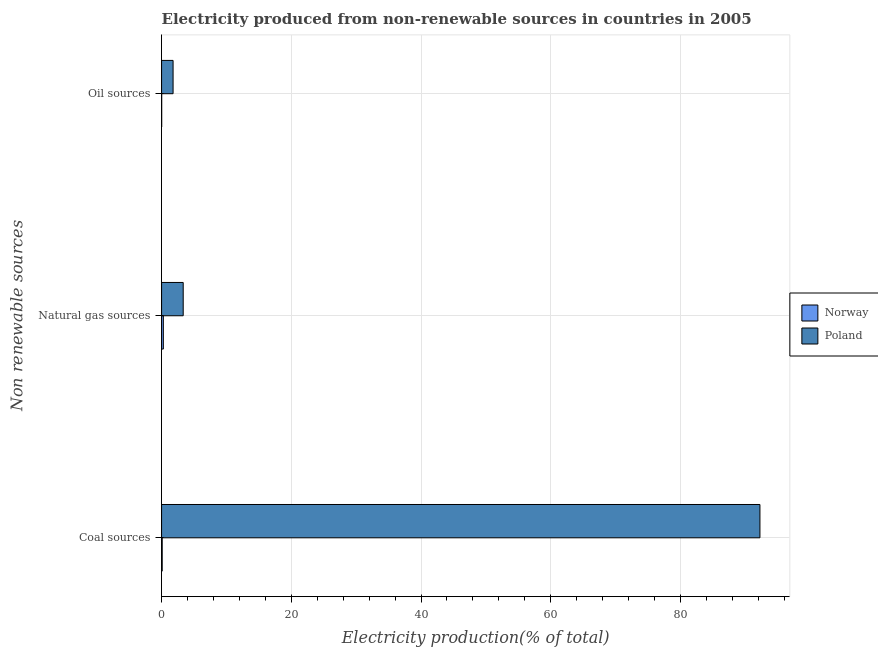How many different coloured bars are there?
Provide a short and direct response. 2. Are the number of bars per tick equal to the number of legend labels?
Offer a terse response. Yes. How many bars are there on the 3rd tick from the bottom?
Make the answer very short. 2. What is the label of the 3rd group of bars from the top?
Your answer should be very brief. Coal sources. What is the percentage of electricity produced by natural gas in Poland?
Give a very brief answer. 3.33. Across all countries, what is the maximum percentage of electricity produced by oil sources?
Offer a terse response. 1.77. Across all countries, what is the minimum percentage of electricity produced by natural gas?
Keep it short and to the point. 0.27. What is the total percentage of electricity produced by oil sources in the graph?
Make the answer very short. 1.79. What is the difference between the percentage of electricity produced by natural gas in Norway and that in Poland?
Make the answer very short. -3.06. What is the difference between the percentage of electricity produced by coal in Norway and the percentage of electricity produced by oil sources in Poland?
Offer a terse response. -1.68. What is the average percentage of electricity produced by natural gas per country?
Give a very brief answer. 1.8. What is the difference between the percentage of electricity produced by coal and percentage of electricity produced by natural gas in Norway?
Make the answer very short. -0.18. What is the ratio of the percentage of electricity produced by natural gas in Poland to that in Norway?
Ensure brevity in your answer.  12.21. What is the difference between the highest and the second highest percentage of electricity produced by natural gas?
Offer a terse response. 3.06. What is the difference between the highest and the lowest percentage of electricity produced by natural gas?
Keep it short and to the point. 3.06. In how many countries, is the percentage of electricity produced by natural gas greater than the average percentage of electricity produced by natural gas taken over all countries?
Offer a very short reply. 1. Is the sum of the percentage of electricity produced by coal in Norway and Poland greater than the maximum percentage of electricity produced by natural gas across all countries?
Provide a short and direct response. Yes. What does the 1st bar from the top in Oil sources represents?
Provide a succinct answer. Poland. Is it the case that in every country, the sum of the percentage of electricity produced by coal and percentage of electricity produced by natural gas is greater than the percentage of electricity produced by oil sources?
Offer a very short reply. Yes. How many bars are there?
Keep it short and to the point. 6. Are all the bars in the graph horizontal?
Provide a succinct answer. Yes. How many countries are there in the graph?
Give a very brief answer. 2. How are the legend labels stacked?
Offer a terse response. Vertical. What is the title of the graph?
Keep it short and to the point. Electricity produced from non-renewable sources in countries in 2005. What is the label or title of the Y-axis?
Provide a short and direct response. Non renewable sources. What is the Electricity production(% of total) in Norway in Coal sources?
Ensure brevity in your answer.  0.1. What is the Electricity production(% of total) in Poland in Coal sources?
Give a very brief answer. 92.26. What is the Electricity production(% of total) of Norway in Natural gas sources?
Ensure brevity in your answer.  0.27. What is the Electricity production(% of total) of Poland in Natural gas sources?
Provide a short and direct response. 3.33. What is the Electricity production(% of total) in Norway in Oil sources?
Offer a very short reply. 0.02. What is the Electricity production(% of total) in Poland in Oil sources?
Keep it short and to the point. 1.77. Across all Non renewable sources, what is the maximum Electricity production(% of total) in Norway?
Make the answer very short. 0.27. Across all Non renewable sources, what is the maximum Electricity production(% of total) in Poland?
Your answer should be very brief. 92.26. Across all Non renewable sources, what is the minimum Electricity production(% of total) of Norway?
Make the answer very short. 0.02. Across all Non renewable sources, what is the minimum Electricity production(% of total) of Poland?
Ensure brevity in your answer.  1.77. What is the total Electricity production(% of total) of Norway in the graph?
Your response must be concise. 0.39. What is the total Electricity production(% of total) in Poland in the graph?
Make the answer very short. 97.37. What is the difference between the Electricity production(% of total) of Norway in Coal sources and that in Natural gas sources?
Keep it short and to the point. -0.18. What is the difference between the Electricity production(% of total) in Poland in Coal sources and that in Natural gas sources?
Your answer should be compact. 88.93. What is the difference between the Electricity production(% of total) of Norway in Coal sources and that in Oil sources?
Your response must be concise. 0.08. What is the difference between the Electricity production(% of total) in Poland in Coal sources and that in Oil sources?
Make the answer very short. 90.49. What is the difference between the Electricity production(% of total) in Norway in Natural gas sources and that in Oil sources?
Offer a very short reply. 0.26. What is the difference between the Electricity production(% of total) in Poland in Natural gas sources and that in Oil sources?
Ensure brevity in your answer.  1.56. What is the difference between the Electricity production(% of total) in Norway in Coal sources and the Electricity production(% of total) in Poland in Natural gas sources?
Your answer should be very brief. -3.24. What is the difference between the Electricity production(% of total) in Norway in Coal sources and the Electricity production(% of total) in Poland in Oil sources?
Provide a short and direct response. -1.68. What is the difference between the Electricity production(% of total) in Norway in Natural gas sources and the Electricity production(% of total) in Poland in Oil sources?
Ensure brevity in your answer.  -1.5. What is the average Electricity production(% of total) of Norway per Non renewable sources?
Your answer should be compact. 0.13. What is the average Electricity production(% of total) in Poland per Non renewable sources?
Ensure brevity in your answer.  32.46. What is the difference between the Electricity production(% of total) in Norway and Electricity production(% of total) in Poland in Coal sources?
Keep it short and to the point. -92.17. What is the difference between the Electricity production(% of total) in Norway and Electricity production(% of total) in Poland in Natural gas sources?
Keep it short and to the point. -3.06. What is the difference between the Electricity production(% of total) of Norway and Electricity production(% of total) of Poland in Oil sources?
Ensure brevity in your answer.  -1.76. What is the ratio of the Electricity production(% of total) of Norway in Coal sources to that in Natural gas sources?
Provide a short and direct response. 0.35. What is the ratio of the Electricity production(% of total) of Poland in Coal sources to that in Natural gas sources?
Your answer should be compact. 27.67. What is the ratio of the Electricity production(% of total) of Norway in Coal sources to that in Oil sources?
Keep it short and to the point. 5.74. What is the ratio of the Electricity production(% of total) of Poland in Coal sources to that in Oil sources?
Your answer should be very brief. 51.99. What is the ratio of the Electricity production(% of total) in Norway in Natural gas sources to that in Oil sources?
Offer a terse response. 16.3. What is the ratio of the Electricity production(% of total) in Poland in Natural gas sources to that in Oil sources?
Provide a succinct answer. 1.88. What is the difference between the highest and the second highest Electricity production(% of total) of Norway?
Keep it short and to the point. 0.18. What is the difference between the highest and the second highest Electricity production(% of total) of Poland?
Your answer should be very brief. 88.93. What is the difference between the highest and the lowest Electricity production(% of total) in Norway?
Provide a succinct answer. 0.26. What is the difference between the highest and the lowest Electricity production(% of total) of Poland?
Your answer should be compact. 90.49. 